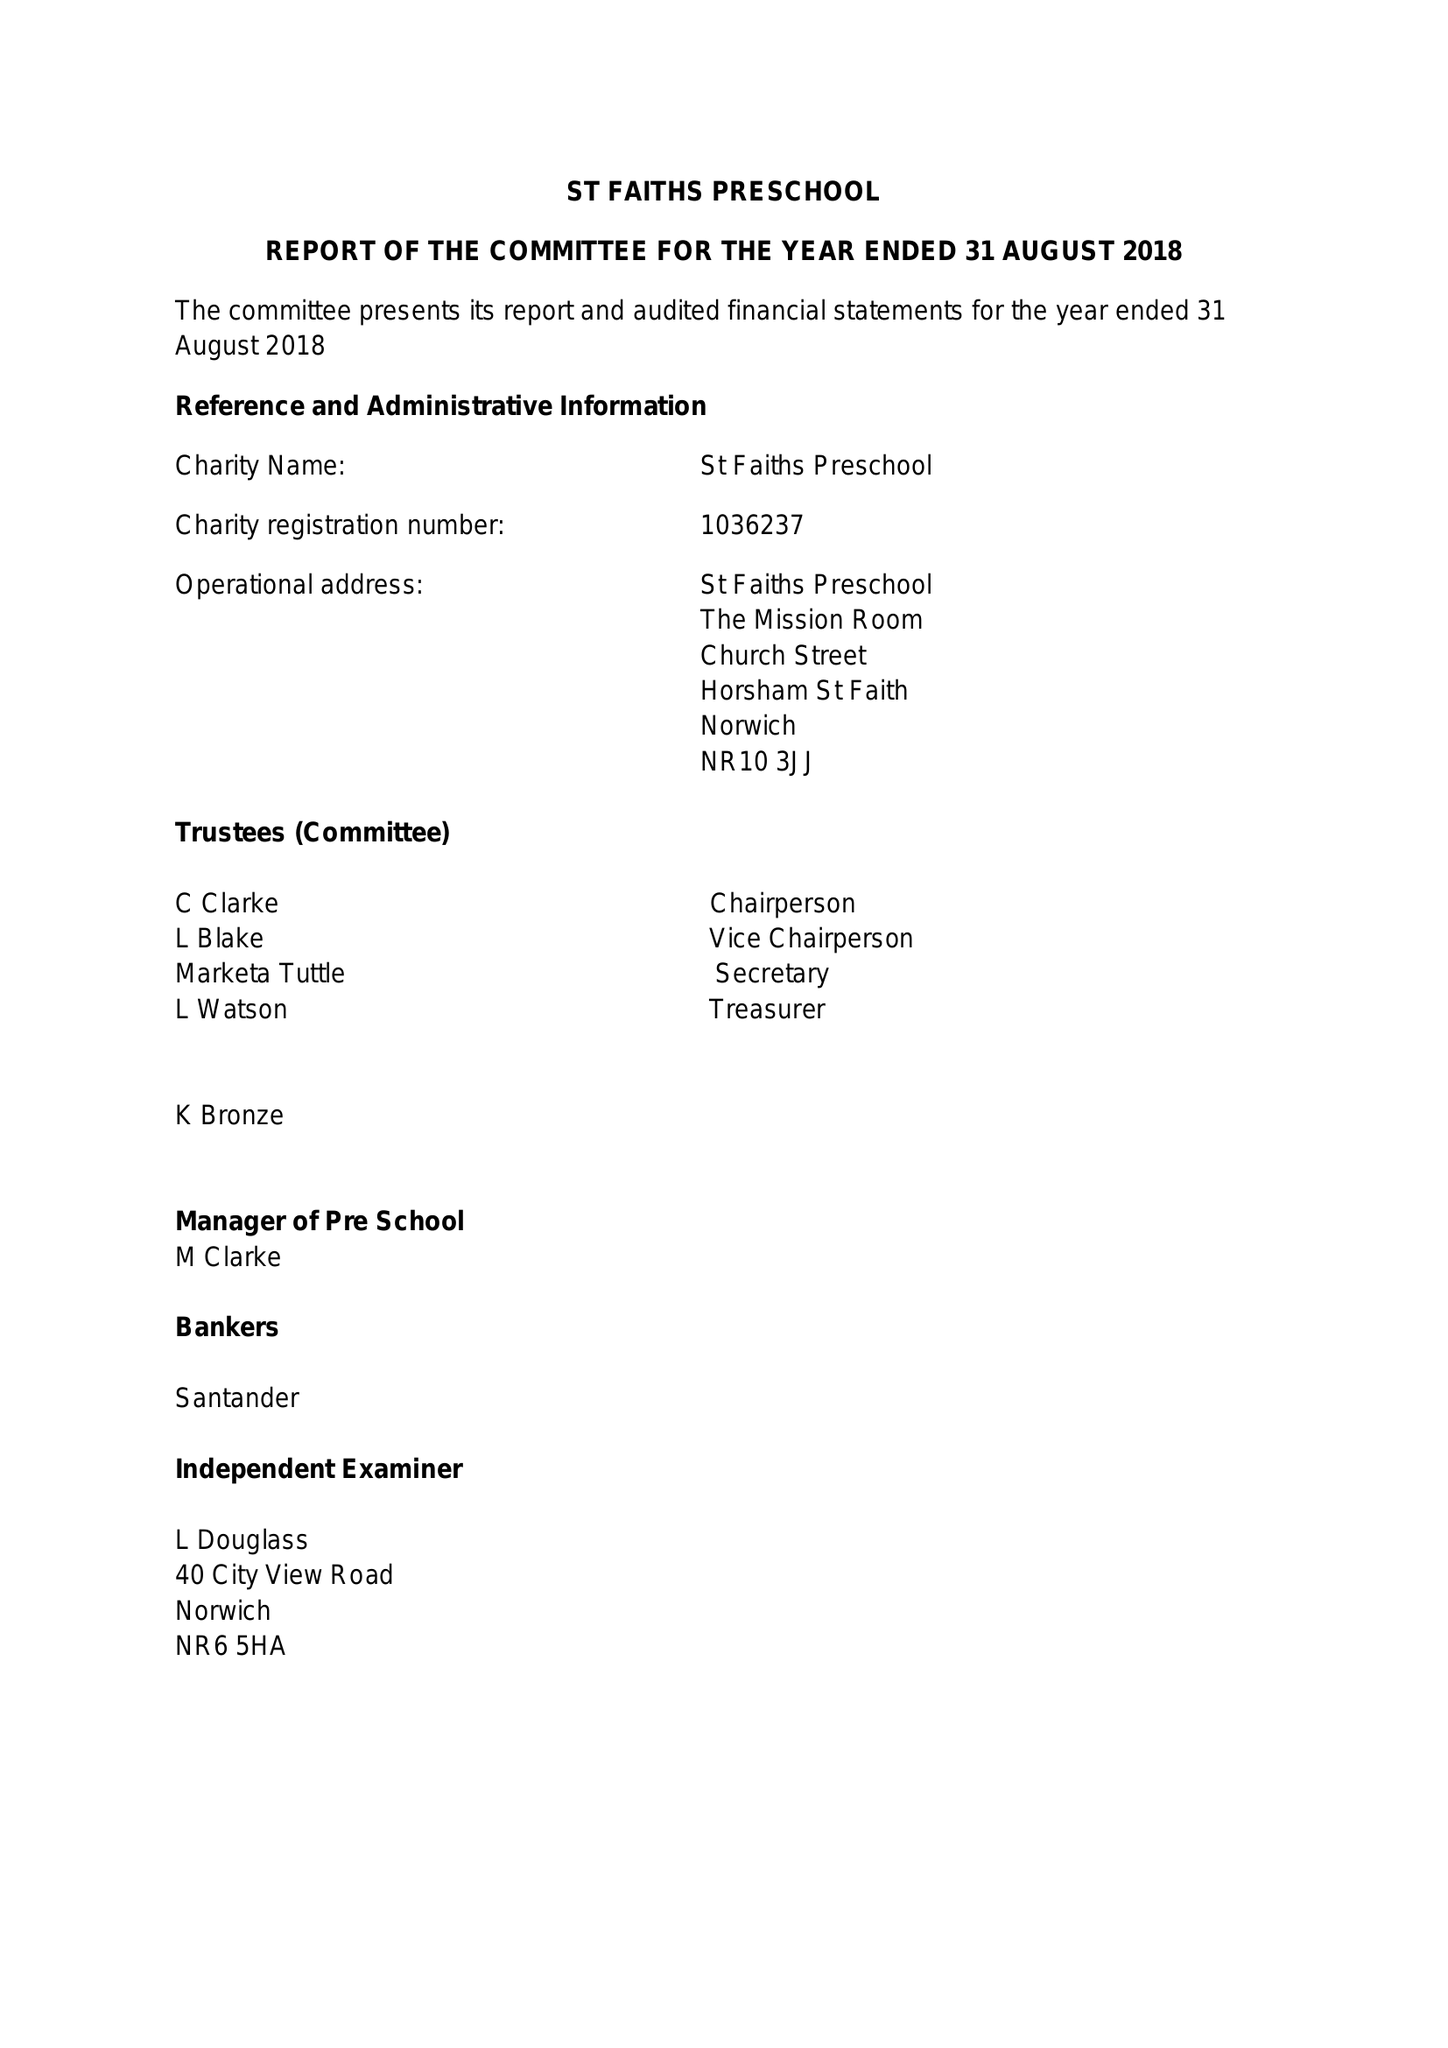What is the value for the charity_number?
Answer the question using a single word or phrase. 1036237 